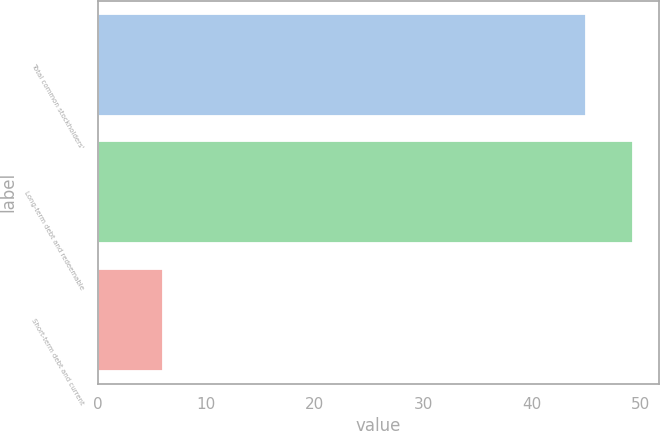<chart> <loc_0><loc_0><loc_500><loc_500><bar_chart><fcel>Total common stockholders'<fcel>Long-term debt and redeemable<fcel>Short-term debt and current<nl><fcel>45<fcel>49.3<fcel>6<nl></chart> 